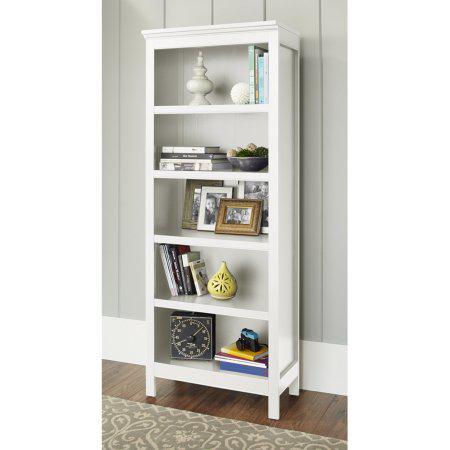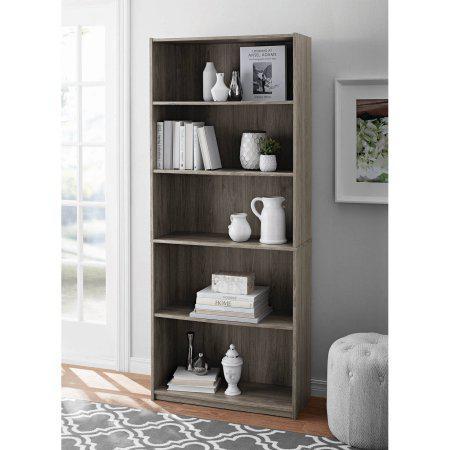The first image is the image on the left, the second image is the image on the right. For the images shown, is this caption "One of the bookshelves is white." true? Answer yes or no. Yes. 